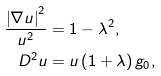Convert formula to latex. <formula><loc_0><loc_0><loc_500><loc_500>\frac { \left | \nabla u \right | ^ { 2 } } { u ^ { 2 } } & = 1 - \lambda ^ { 2 } , \\ D ^ { 2 } u & = u \left ( 1 + \lambda \right ) g _ { 0 } ,</formula> 